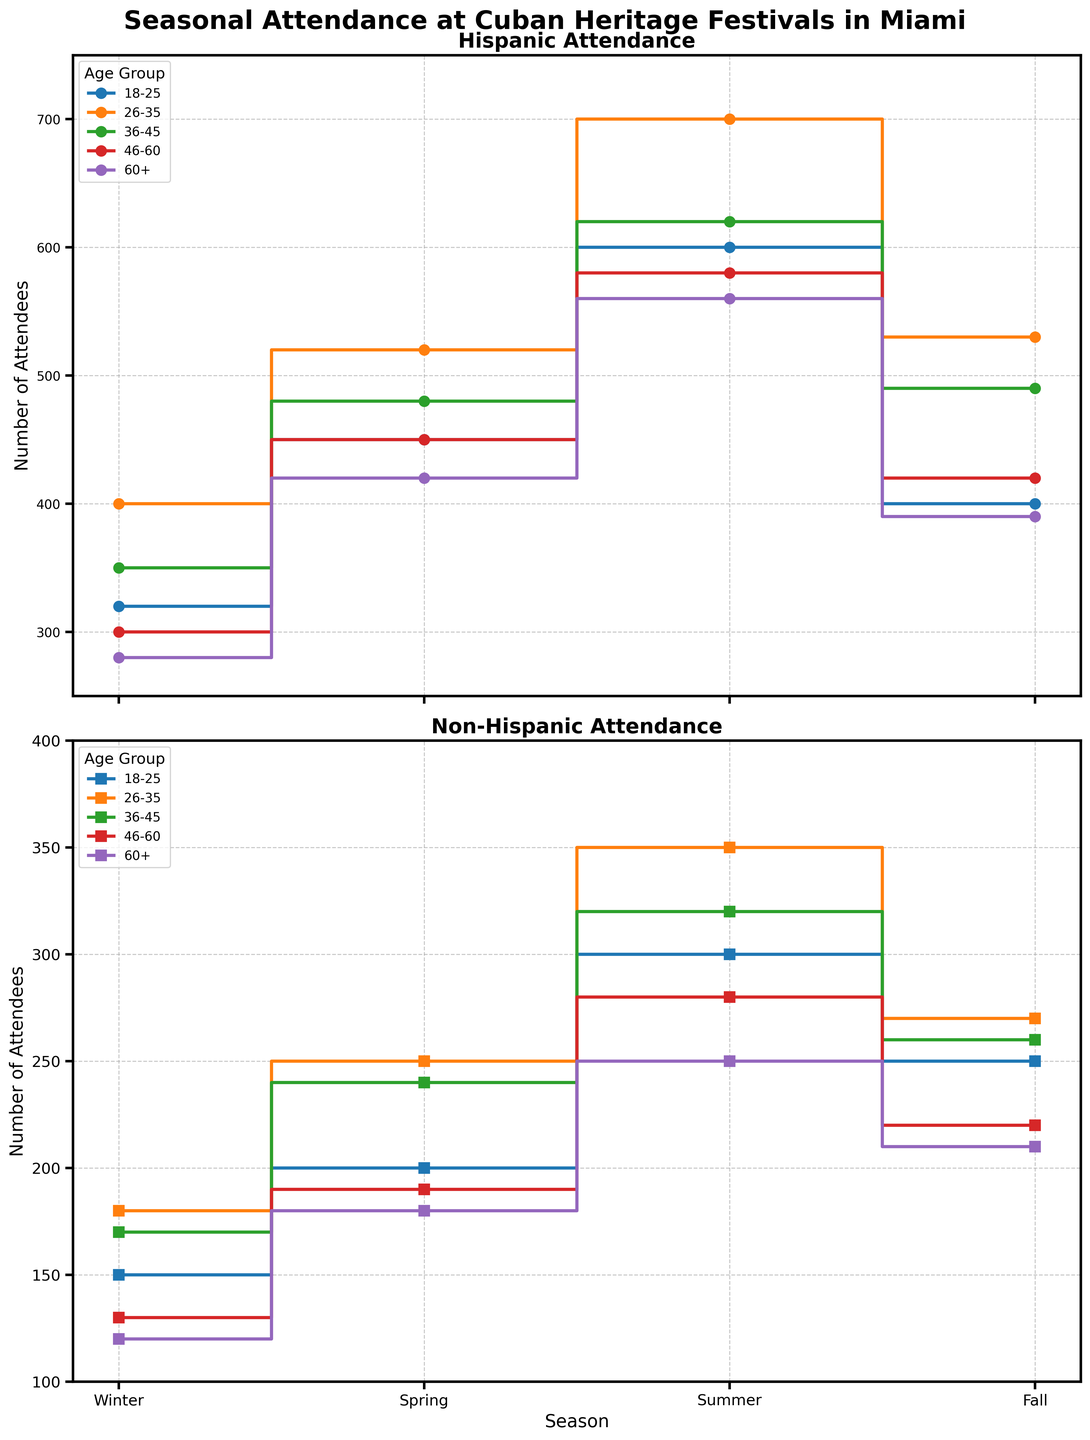What is the title of the figure? The title is the large text at the top of the figure. It summarizes the main topic being presented.
Answer: Seasonal Attendance at Cuban Heritage Festivals in Miami Which age group shows the highest attendance in the Hispanic community during the summer? Look within the lines labeled "Hispanic Attendance" and find the maximum value in the summer season, then identify the age group associated with that value.
Answer: 26-35 How does the attendance of the 18-25 age group compare between Hispanic and Non-Hispanic communities in the spring? Look at the lines for both ethnicities in the spring season and compare the attendance figures for the 18-25 age group.
Answer: Hispanic has higher attendance at 450, compared to Non-Hispanic at 200 What is the average attendance for Non-Hispanic individuals in the 36-45 age group across all seasons? Sum the attendance numbers for Non-Hispanics in the 36-45 age group across Winter, Spring, Summer, and Fall, then divide by the number of seasons (4). (170+240+320+260)/4 = 990/4 = 247.5
Answer: 247.5 During which season is the attendance the lowest for the 46-60 age group in the Hispanic community? Identify the lowest attendance number for the 46-60 Hispanic group across all four seasons.
Answer: Winter Does the Hispanic 60+ age group show a consistent increase or decrease in attendance across the seasons? Compare the attendance values for the Hispanic 60+ age group across Winter, Spring, Summer, and Fall and observe the trend. The values are 280, 420, 560, then 390, showing an increase in Winter to Summer, followed by a decrease in Fall.
Answer: It shows an increase and then a decrease What is the difference in summer attendance between Non-Hispanic and Hispanic individuals in the 26-35 age group? Subtract the summer attendance figure of Non-Hispanic 26-35 from the Hispanic 26-35. 700 (Hispanic) - 350 (Non-Hispanic) = 350.
Answer: 350 How does the fall attendance of the 36-45 age group compare between the Hispanic and Non-Hispanic communities? Identify the attendance figures for the 36-45 age group in the fall for both Hispanic and Non-Hispanic communities and compare them. 490 (Hispanic) vs. 260 (Non-Hispanic).
Answer: Hispanic has higher attendance 